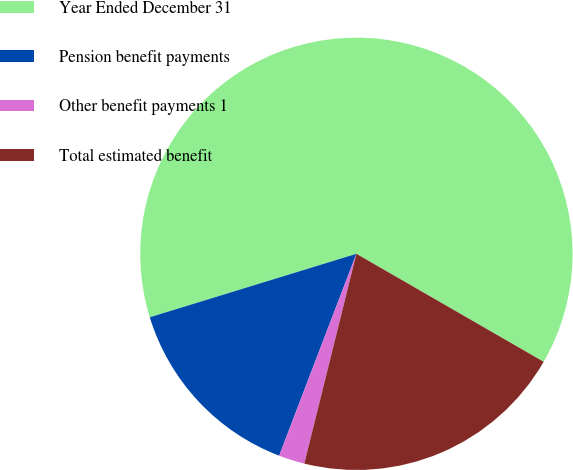<chart> <loc_0><loc_0><loc_500><loc_500><pie_chart><fcel>Year Ended December 31<fcel>Pension benefit payments<fcel>Other benefit payments 1<fcel>Total estimated benefit<nl><fcel>63.06%<fcel>14.44%<fcel>1.94%<fcel>20.55%<nl></chart> 